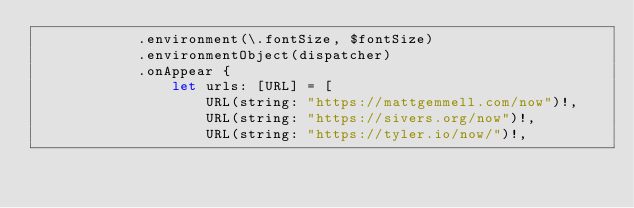<code> <loc_0><loc_0><loc_500><loc_500><_Swift_>            .environment(\.fontSize, $fontSize)
            .environmentObject(dispatcher)
            .onAppear {
                let urls: [URL] = [
                    URL(string: "https://mattgemmell.com/now")!,
                    URL(string: "https://sivers.org/now")!,
                    URL(string: "https://tyler.io/now/")!,</code> 